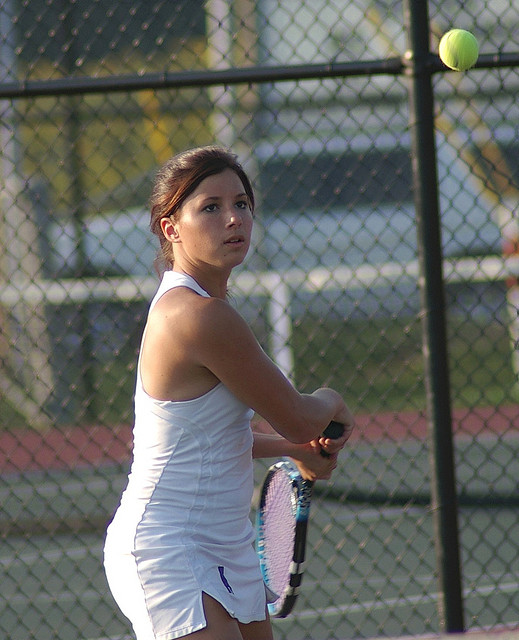<image>What color are the girl's shorts? I am not sure about the color of the girl's shorts, but it could be white. What color are the girl's shorts? The girl's shorts are white. 